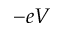Convert formula to latex. <formula><loc_0><loc_0><loc_500><loc_500>- e V</formula> 